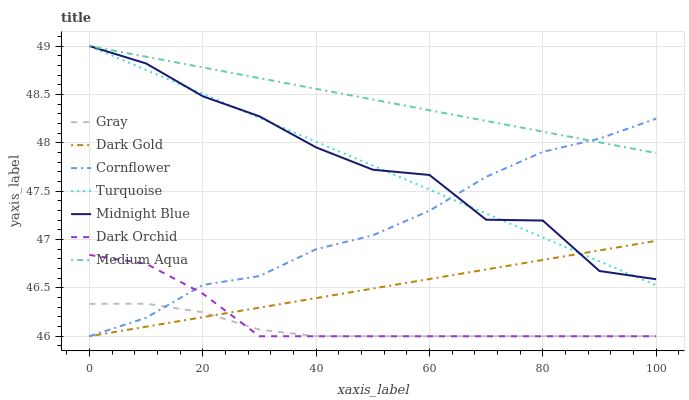Does Gray have the minimum area under the curve?
Answer yes or no. Yes. Does Medium Aqua have the maximum area under the curve?
Answer yes or no. Yes. Does Turquoise have the minimum area under the curve?
Answer yes or no. No. Does Turquoise have the maximum area under the curve?
Answer yes or no. No. Is Dark Gold the smoothest?
Answer yes or no. Yes. Is Midnight Blue the roughest?
Answer yes or no. Yes. Is Turquoise the smoothest?
Answer yes or no. No. Is Turquoise the roughest?
Answer yes or no. No. Does Gray have the lowest value?
Answer yes or no. Yes. Does Turquoise have the lowest value?
Answer yes or no. No. Does Medium Aqua have the highest value?
Answer yes or no. Yes. Does Cornflower have the highest value?
Answer yes or no. No. Is Dark Orchid less than Turquoise?
Answer yes or no. Yes. Is Turquoise greater than Dark Orchid?
Answer yes or no. Yes. Does Midnight Blue intersect Turquoise?
Answer yes or no. Yes. Is Midnight Blue less than Turquoise?
Answer yes or no. No. Is Midnight Blue greater than Turquoise?
Answer yes or no. No. Does Dark Orchid intersect Turquoise?
Answer yes or no. No. 